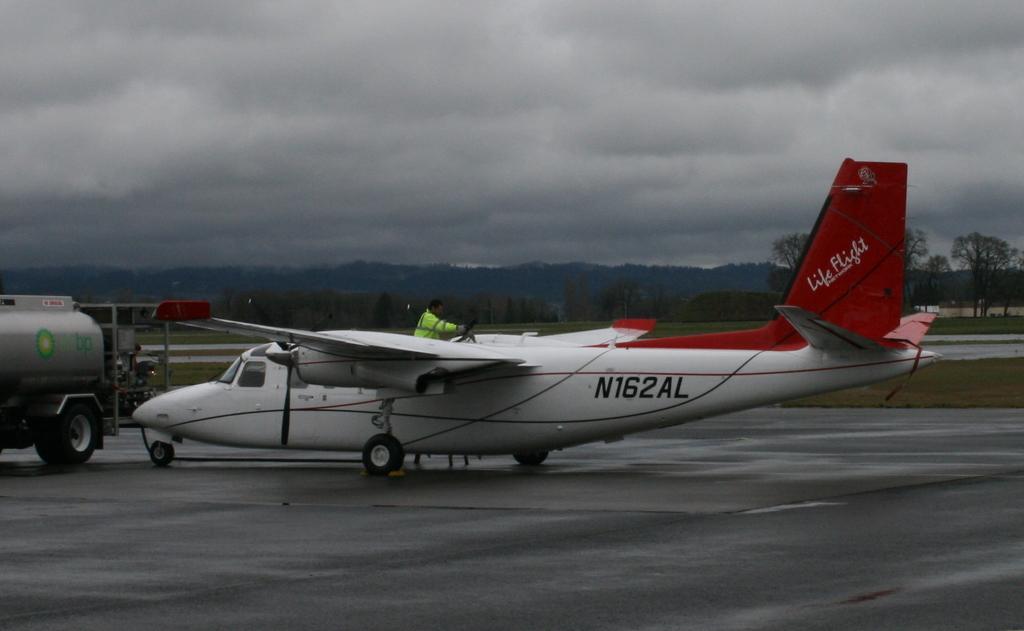Could you give a brief overview of what you see in this image? In this image I can see a vehicle and an aircraft in the front. Behind the aircraft I can see one man is standing and I can see he is wearing neon colour jacket. In the background I can see an open grass ground, number of trees, clouds and the sky. I can also see something is written on the aircraft and on the vehicle. 